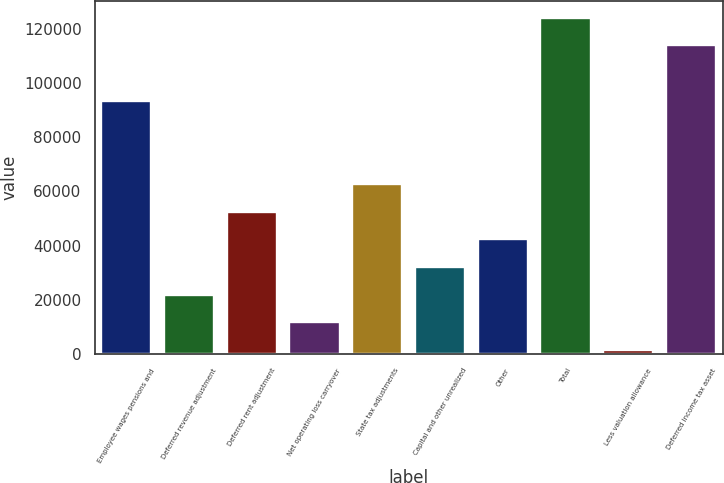Convert chart. <chart><loc_0><loc_0><loc_500><loc_500><bar_chart><fcel>Employee wages pensions and<fcel>Deferred revenue adjustment<fcel>Deferred rent adjustment<fcel>Net operating loss carryover<fcel>State tax adjustments<fcel>Capital and other unrealized<fcel>Other<fcel>Total<fcel>Less valuation allowance<fcel>Deferred income tax asset<nl><fcel>93453.3<fcel>21922.4<fcel>52578.5<fcel>11703.7<fcel>62797.2<fcel>32141.1<fcel>42359.8<fcel>124109<fcel>1485<fcel>113891<nl></chart> 